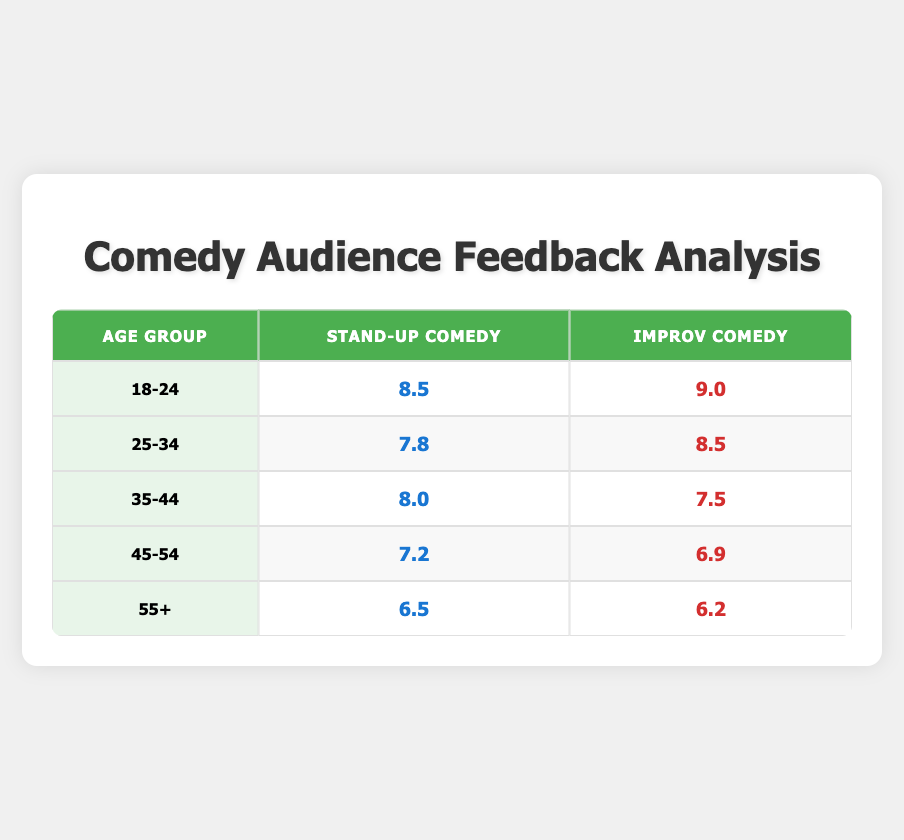What is the feedback score for Improv Comedy for the age group 25-34? According to the table, the feedback score for Improv Comedy for the age group 25-34 is listed directly under that category.
Answer: 8.5 Which age group has the highest feedback score for Stand-Up Comedy? By reviewing the Stand-Up Comedy scores across each age group, 18-24 has a score of 8.5, which is the highest compared to other age groups: 7.8 (25-34), 8.0 (35-44), 7.2 (45-54), and 6.5 (55+).
Answer: 18-24 Is the feedback score for Improv Comedy higher than for Stand-Up Comedy in the age group 35-44? The Improv Comedy score for age group 35-44 is 7.5, while for Stand-Up Comedy it is 8.0. Since 8.0 is greater than 7.5, the feedback score for Improv Comedy is not higher.
Answer: No What is the average feedback score for Stand-Up Comedy across all age groups? To find the average score, we add all the feedback scores for Stand-Up Comedy: 8.5 (18-24) + 7.8 (25-34) + 8.0 (35-44) + 7.2 (45-54) + 6.5 (55+) = 38.0. Then, we divide by the number of age groups, which is 5. So, 38.0/5 = 7.6 is the average score.
Answer: 7.6 Is the feedback score for Improv Comedy in the age group 45-54 lower than that for 55+? Looking at the table, the score for Improv Comedy in the age group 45-54 is 6.9, while for 55+ it is 6.2. Since 6.9 is greater than 6.2, we conclude that the score for 45-54 is not lower.
Answer: No Which type of comedy has a better feedback score on average across all age groups? First, we calculate the average for both types of comedy. For Stand-Up Comedy: (8.5 + 7.8 + 8.0 + 7.2 + 6.5) = 38.0; average = 38.0 / 5 = 7.6. For Improv Comedy: (9.0 + 8.5 + 7.5 + 6.9 + 6.2) = 38.1; average = 38.1 / 5 = 7.62. Then compare both averages; since 7.62 is greater than 7.6, Improv Comedy has a better average score.
Answer: Improv Comedy 